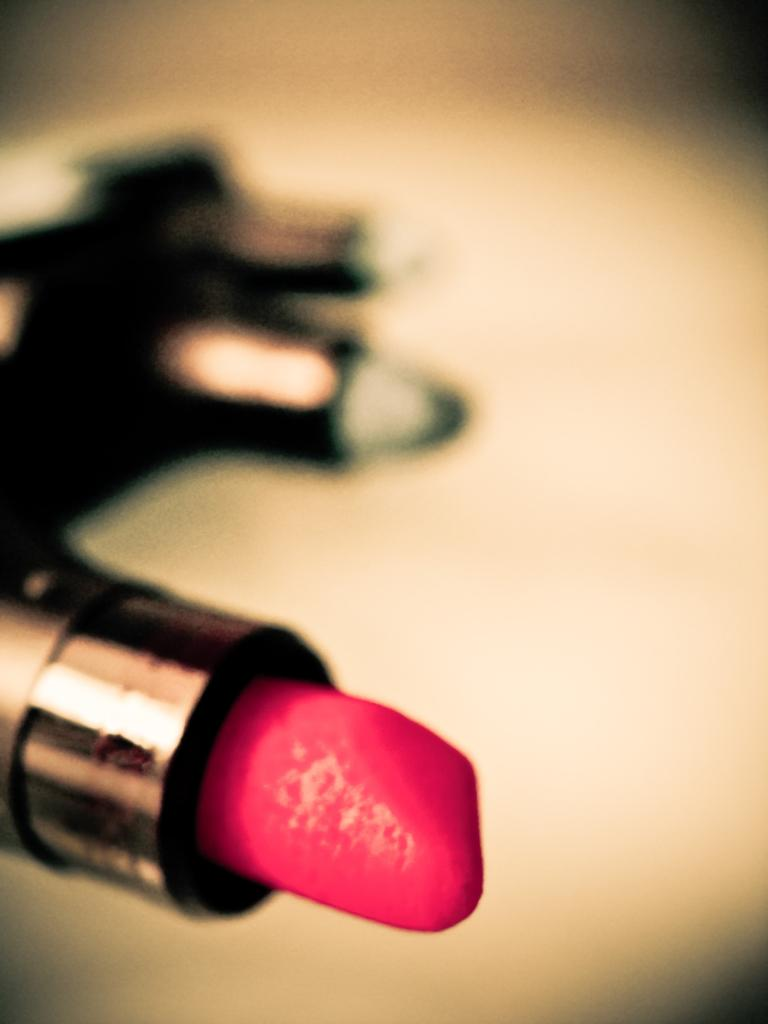What is the main object in the foreground of the image? There is a lipstick in the foreground of the image. Can you describe the background of the image? The background of the image is blurred. What type of dog can be seen playing with a twig in the image? There is no dog or twig present in the image; it only features a lipstick in the foreground and a blurred background. 